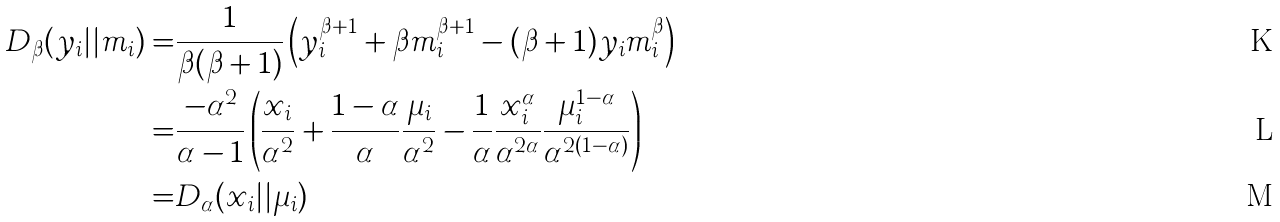Convert formula to latex. <formula><loc_0><loc_0><loc_500><loc_500>D _ { \beta } ( y _ { i } | | m _ { i } ) = & \frac { 1 } { \beta ( \beta + 1 ) } \left ( y _ { i } ^ { \beta + 1 } + \beta m _ { i } ^ { \beta + 1 } - ( \beta + 1 ) y _ { i } m _ { i } ^ { \beta } \right ) \\ = & \frac { - \alpha ^ { 2 } } { \alpha - 1 } \left ( \frac { x _ { i } } { \alpha ^ { 2 } } + \frac { 1 - \alpha } { \alpha } \frac { \mu _ { i } } { \alpha ^ { 2 } } - \frac { 1 } { \alpha } \frac { x _ { i } ^ { \alpha } } { \alpha ^ { 2 \alpha } } \frac { \mu _ { i } ^ { 1 - \alpha } } { \alpha ^ { 2 ( 1 - \alpha ) } } \right ) \\ = & D _ { \alpha } ( x _ { i } | | \mu _ { i } )</formula> 